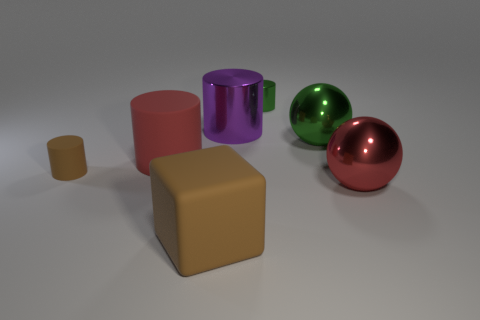Is the shape of the red thing left of the large red metallic object the same as the tiny thing that is right of the big purple object?
Ensure brevity in your answer.  Yes. How many cylinders are either small brown rubber things or large matte things?
Provide a short and direct response. 2. Does the tiny green cylinder have the same material as the tiny brown thing?
Offer a terse response. No. What number of other objects are there of the same color as the small shiny thing?
Give a very brief answer. 1. There is a large rubber thing that is behind the small matte thing; what is its shape?
Offer a very short reply. Cylinder. What number of objects are big cyan rubber spheres or large brown matte blocks?
Give a very brief answer. 1. There is a brown matte cylinder; is it the same size as the matte block that is in front of the small green cylinder?
Make the answer very short. No. What number of other things are made of the same material as the cube?
Your answer should be compact. 2. What number of things are either big spheres that are to the right of the large green ball or cylinders right of the purple metal cylinder?
Your answer should be very brief. 2. There is a tiny green object that is the same shape as the small brown thing; what material is it?
Keep it short and to the point. Metal. 